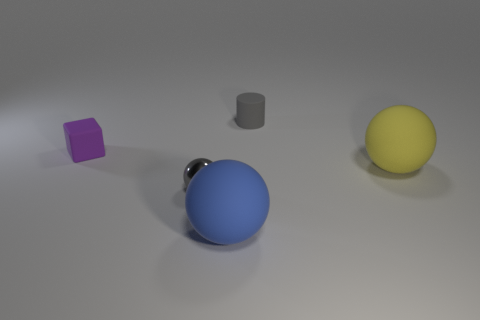Do the small metal thing and the small thing to the right of the gray shiny object have the same color?
Your answer should be very brief. Yes. Do the small rubber object that is to the right of the large blue rubber thing and the tiny object in front of the purple cube have the same color?
Give a very brief answer. Yes. What material is the other large thing that is the same shape as the yellow rubber object?
Offer a very short reply. Rubber. How many matte cylinders have the same color as the small metal sphere?
Keep it short and to the point. 1. There is a blue ball that is the same size as the yellow matte ball; what is its material?
Provide a succinct answer. Rubber. Is the material of the big yellow thing the same as the tiny thing behind the block?
Your answer should be very brief. Yes. There is a tiny rubber cylinder; are there any large blue spheres on the right side of it?
Make the answer very short. No. What number of objects are tiny metal spheres or balls that are to the right of the tiny shiny object?
Keep it short and to the point. 3. The tiny object right of the blue thing that is in front of the gray sphere is what color?
Ensure brevity in your answer.  Gray. What number of other objects are the same material as the small purple block?
Keep it short and to the point. 3. 